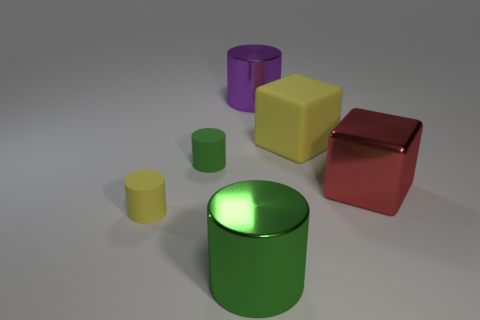Add 4 small gray spheres. How many objects exist? 10 Subtract all green cylinders. How many cylinders are left? 2 Subtract 0 purple blocks. How many objects are left? 6 Subtract all cylinders. How many objects are left? 2 Subtract 1 cubes. How many cubes are left? 1 Subtract all cyan blocks. Subtract all cyan cylinders. How many blocks are left? 2 Subtract all red blocks. How many cyan cylinders are left? 0 Subtract all tiny green objects. Subtract all metallic cylinders. How many objects are left? 3 Add 2 red blocks. How many red blocks are left? 3 Add 4 shiny cylinders. How many shiny cylinders exist? 6 